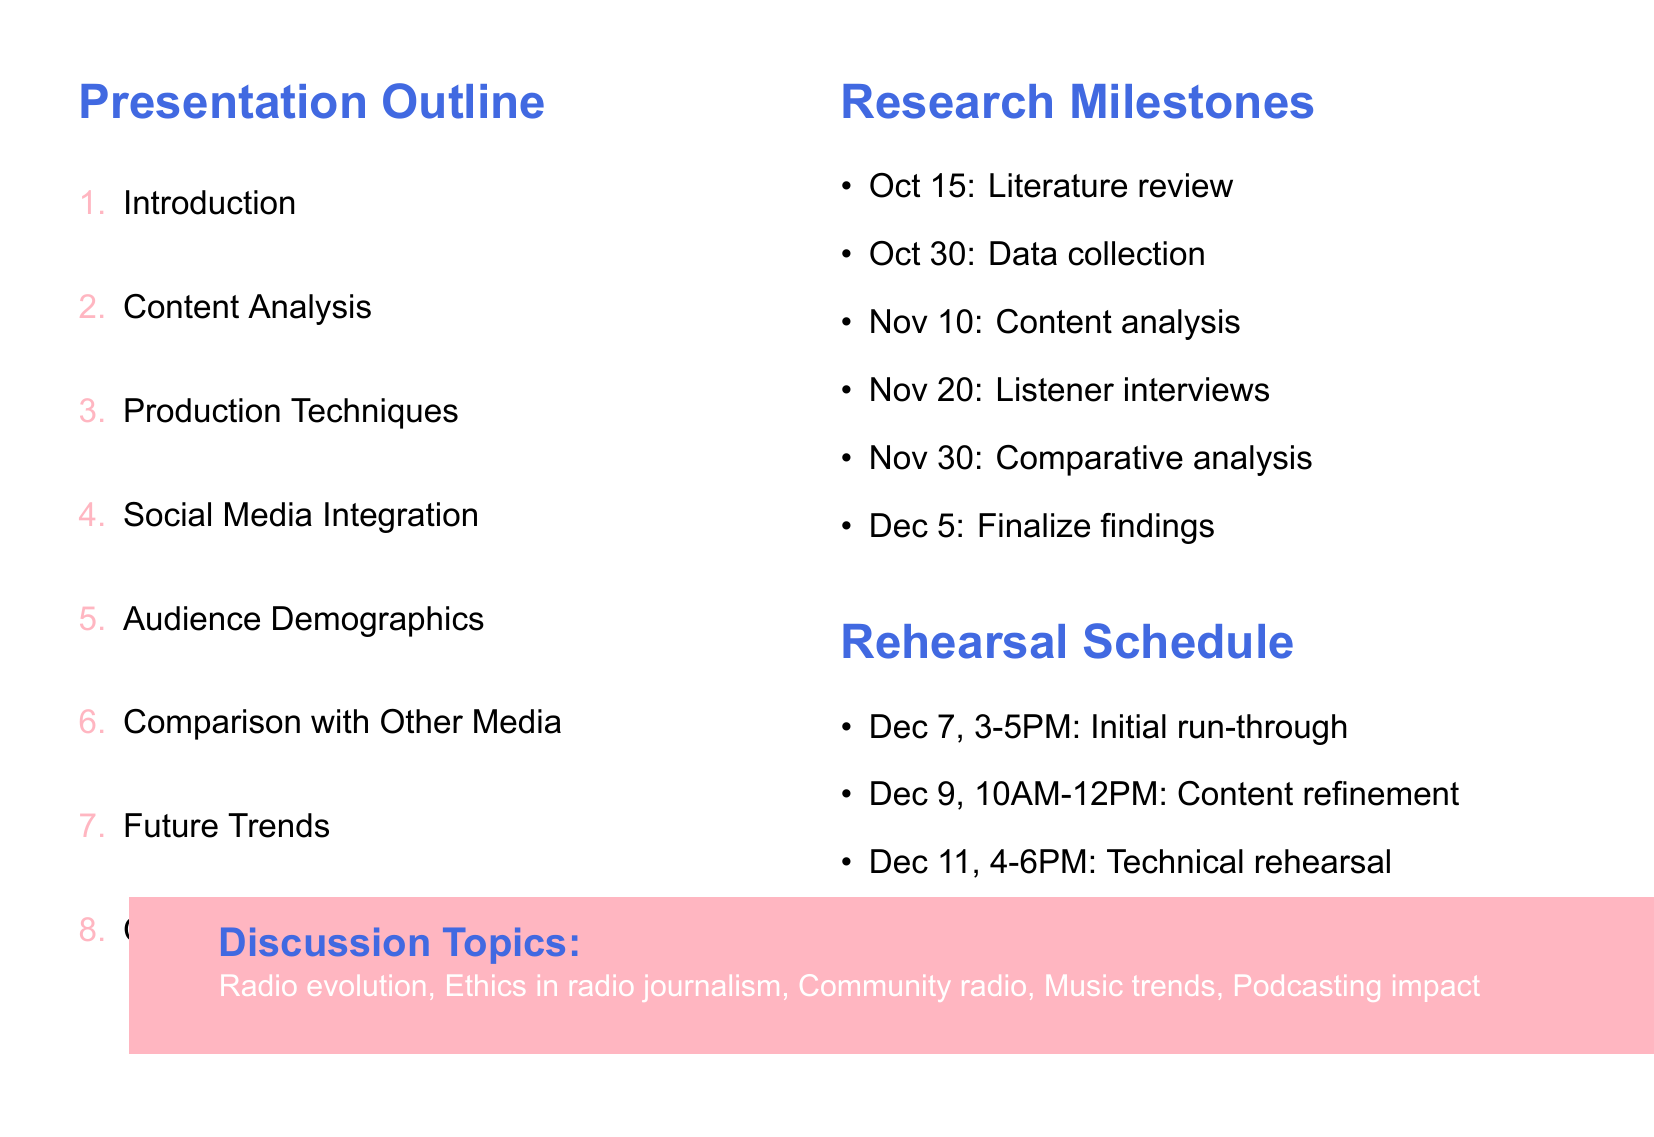What is the title of the presentation agenda? The title of the presentation agenda is indicated at the top of the document.
Answer: Radio Show Presentation Agenda When is the literature review due? The due date for the literature review is mentioned in the research milestones section.
Answer: October 15, 2023 What is the focus of the rehearsal on December 11? The focus of the rehearsal is listed under the rehearsal schedule.
Answer: Technical rehearsal with audio-visual equipment How many subsections are in the "Production Techniques" section? The number of subsections in each section is specified in the outline.
Answer: Three What are discussed as potential future trends in radio broadcasting? The future trends mentioned are outlined in the specified section of the document.
Answer: Emerging technologies in radio broadcasting What platform is suggested for conducting remote listener interviews? The resources needed for the project include suggested platforms.
Answer: Zoom What time is the final dress rehearsal scheduled for? The timing for the final dress rehearsal is provided in the rehearsal schedule.
Answer: 2:00 PM - 4:00 PM Which section contains guest interview highlights? The section for guest interview highlights can be found by reviewing subsection listings.
Answer: Content Analysis What is one topic for class discussion listed in the document? The topics for class discussion are listed toward the end of the document.
Answer: Ethical considerations in radio journalism 